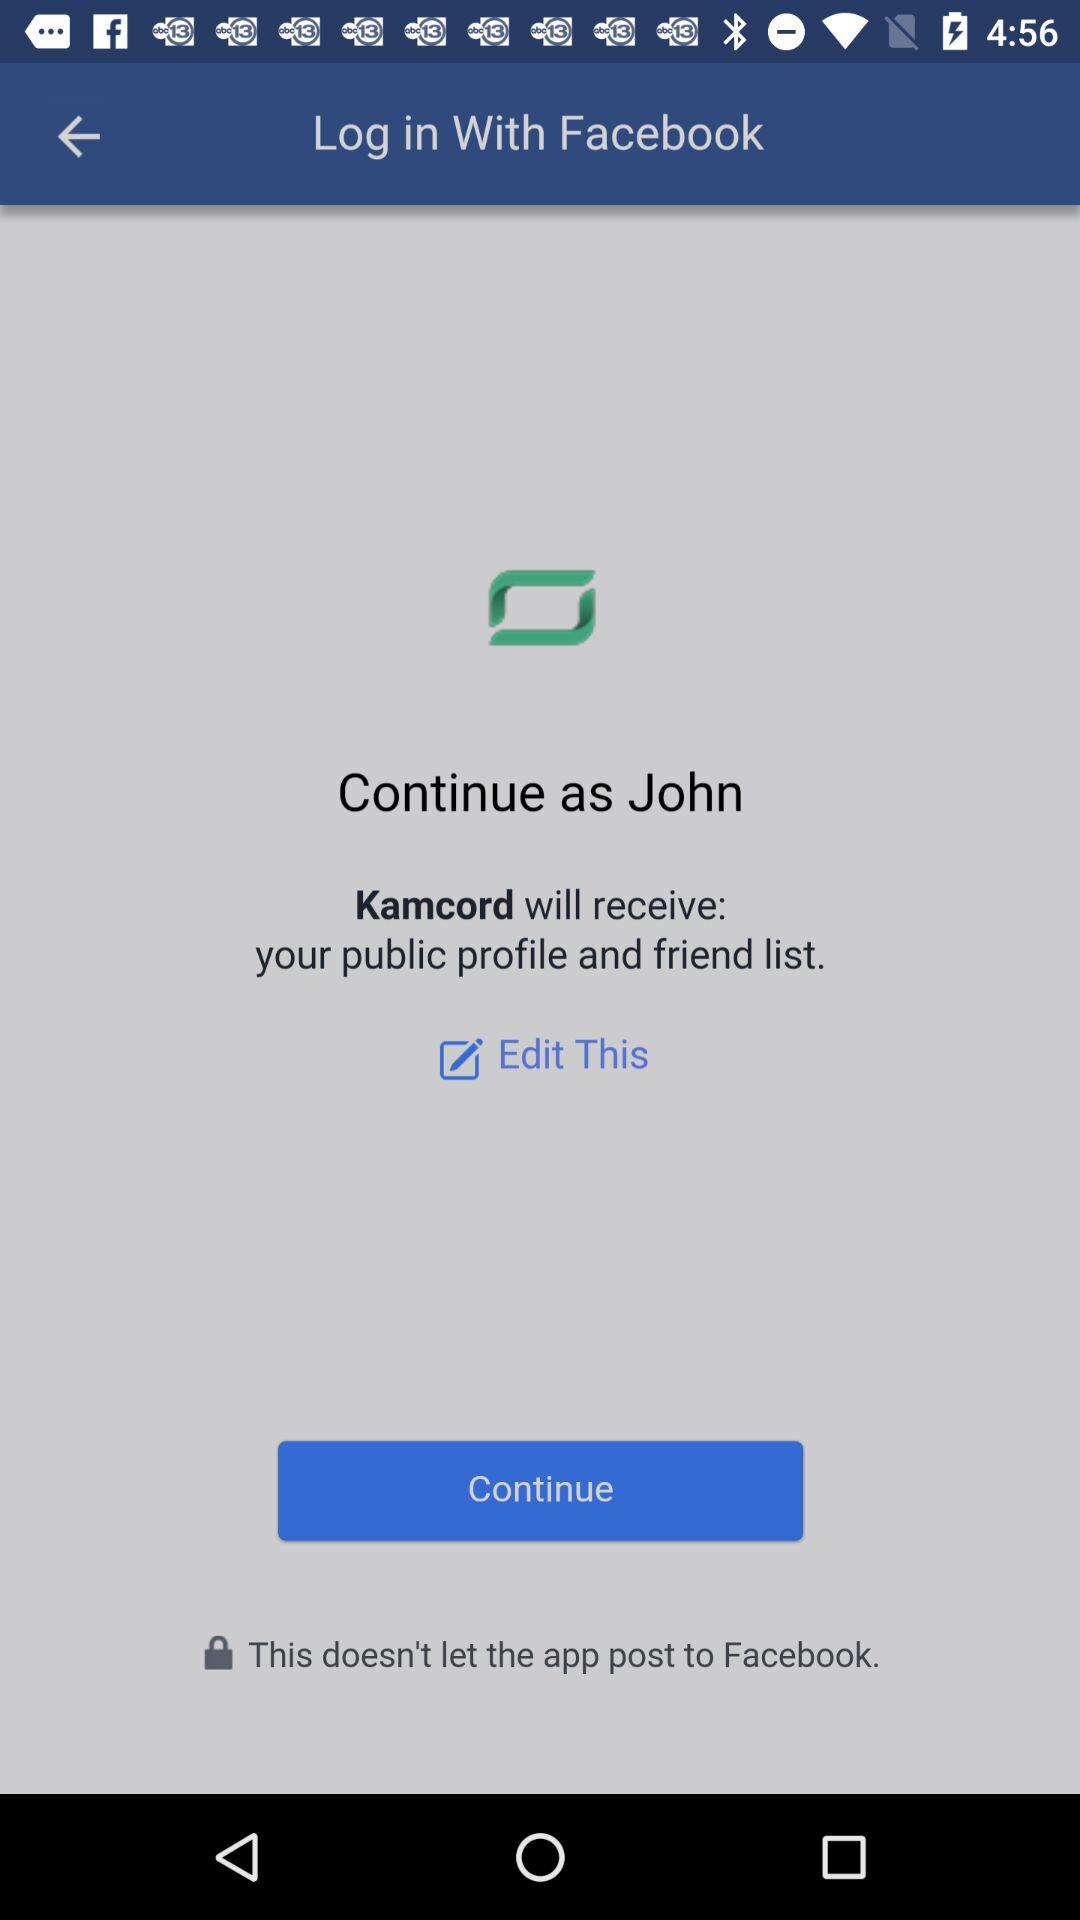What is the login name? The login name is John. 